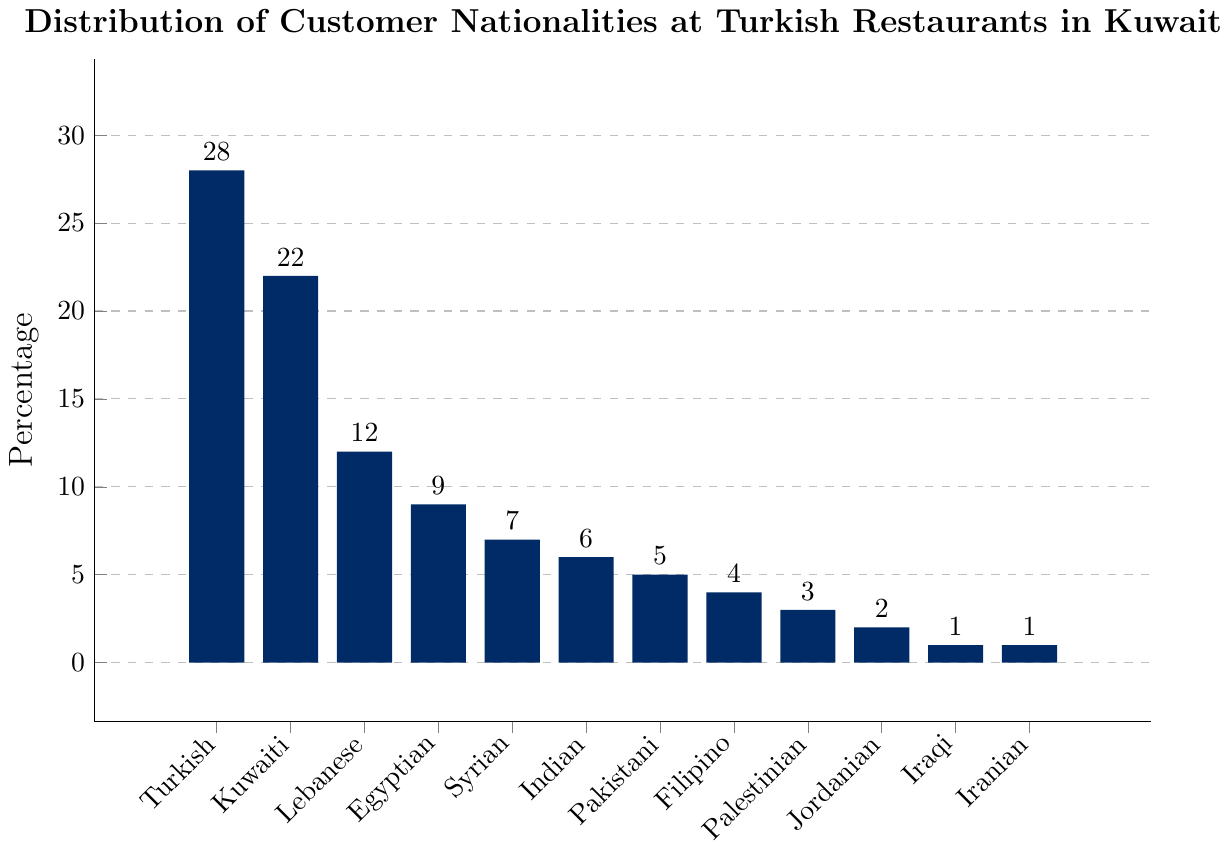What's the most represented nationality among the customers at Turkish restaurants in Kuwait? The tallest bar in the chart is labeled "Turkish" and reaches the highest percentage value.
Answer: Turkish Which two nationalities combined account for more than 50% of the customers? By examining the chart, Turkish customers account for 28% and Kuwaiti customers for 22%. The combined percentage is 28% + 22% = 50%, thus meeting the condition.
Answer: Turkish and Kuwaiti How does the percentage of Lebanese customers compare to that of Egyptian customers? Lebanese customers represent 12% while Egyptian customers represent 9%. Since 12% is greater than 9%, the percentage of Lebanese customers is higher.
Answer: Lebanese customers percentage is higher What is the total percentage of customers from Middle Eastern countries? Adding the percentages of Turkish (28%), Kuwaiti (22%), Lebanese (12%), Egyptian (9%), Syrian (7%), Palestinian (3%), Jordanian (2%), Iraqi (1%), and Iranian (1%) results in 85%.
Answer: 85% Which nationality has the smallest representation at Turkish restaurants in Kuwait? The shortest bars are those labeled "Iraqi" and "Iranian," each representing 1% of the customers.
Answer: Iraqi and Iranian By how much does the percentage of Kuwaiti customers exceed the percentage of Indian customers? Kuwaiti customers are 22% while Indian customers are 6%. The difference is 22% - 6% = 16%.
Answer: 16% What percentage of customers are from South Asian countries (India and Pakistan)? Adding the percentages of Indian (6%) and Pakistani (5%) customers, we get 6% + 5% = 11%.
Answer: 11% Which nationality has a customer percentage closest to that of Filipino customers? Filipino customers make up 4%. The closest neighboring bars are Pakistani at 5% and Palestinian at 3%. The Palestinian percentage is 1% closer to Filipino than Pakistani.
Answer: Palestinian Of the nationalities listed, how many have customer percentages in single digits? Nationalities with single-digit percentages are Egyptian (9%), Syrian (7%), Indian (6%), Pakistani (5%), Filipino (4%), Palestinian (3%), Jordanian (2%), Iraqi (1%), and Iranian (1%). Counting these gives us 9 nationalities.
Answer: 9 What is the mean percentage of customers for the nationalities with the lowest representations (1% each)? The nationalities with the lowest representations are Iraqi and Iranian, both at 1%. The mean is calculated as (1% + 1%) / 2 = 1%.
Answer: 1% 